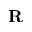<formula> <loc_0><loc_0><loc_500><loc_500>R</formula> 